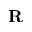<formula> <loc_0><loc_0><loc_500><loc_500>R</formula> 